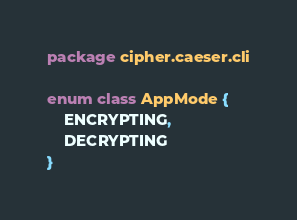Convert code to text. <code><loc_0><loc_0><loc_500><loc_500><_Kotlin_>package cipher.caeser.cli

enum class AppMode {
    ENCRYPTING,
    DECRYPTING
}</code> 